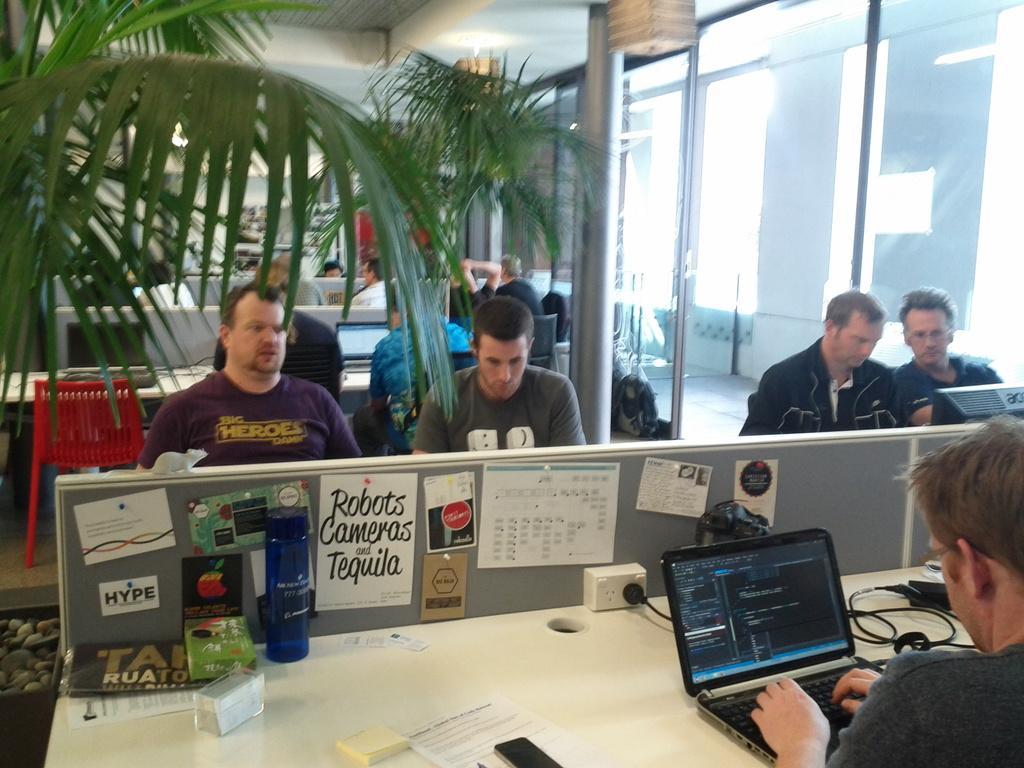In one or two sentences, can you explain what this image depicts? In this image there are group of people sitting on the chair. On the table there is a laptop,switchboard,wire,boards,bottle and a mobile. At the back side we can see a glass door and there is a flower pot. 